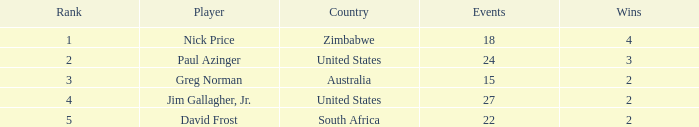How many events are in South Africa? 22.0. 